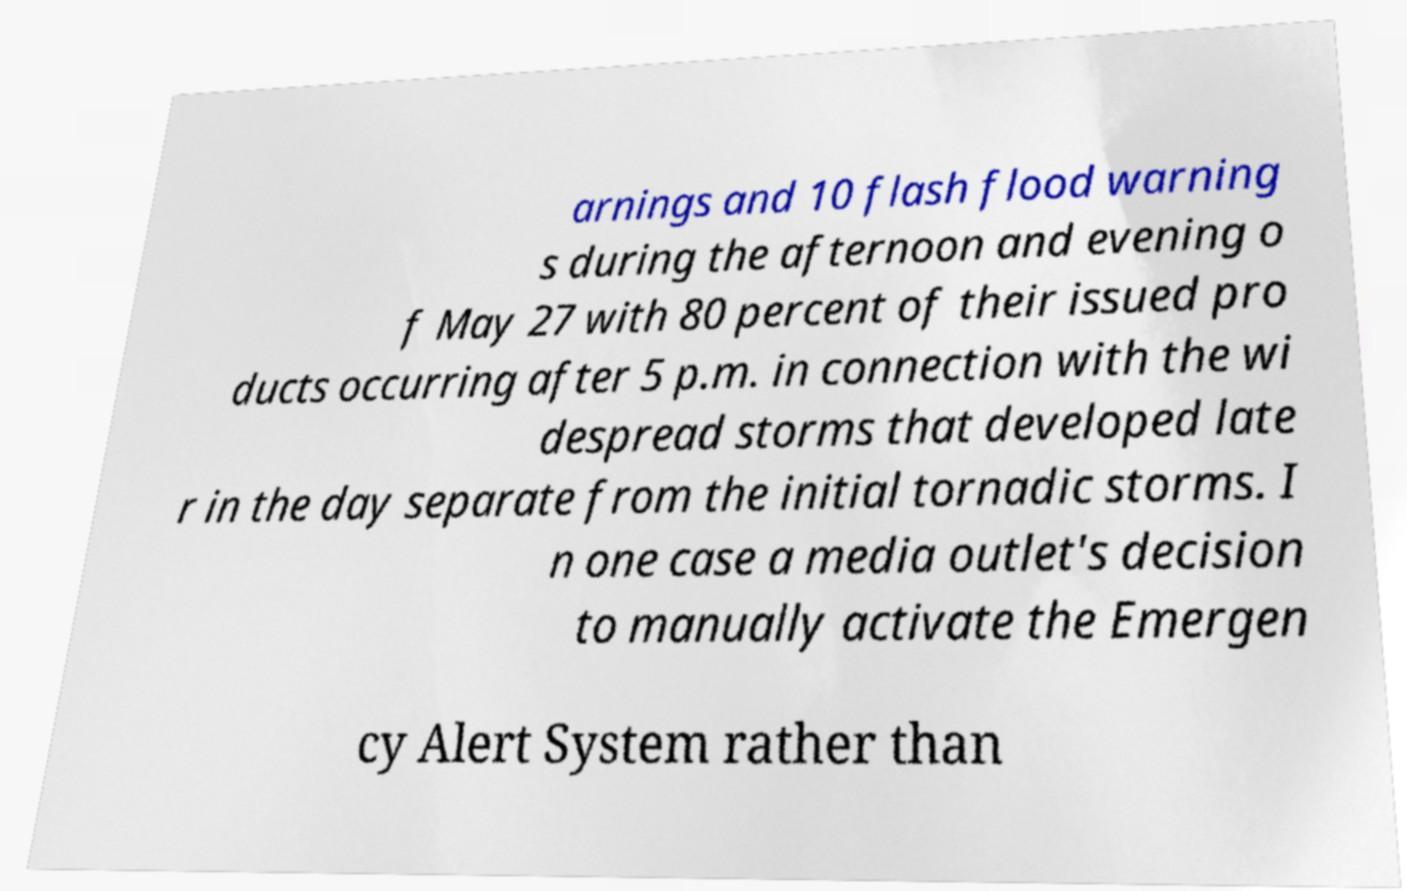I need the written content from this picture converted into text. Can you do that? arnings and 10 flash flood warning s during the afternoon and evening o f May 27 with 80 percent of their issued pro ducts occurring after 5 p.m. in connection with the wi despread storms that developed late r in the day separate from the initial tornadic storms. I n one case a media outlet's decision to manually activate the Emergen cy Alert System rather than 